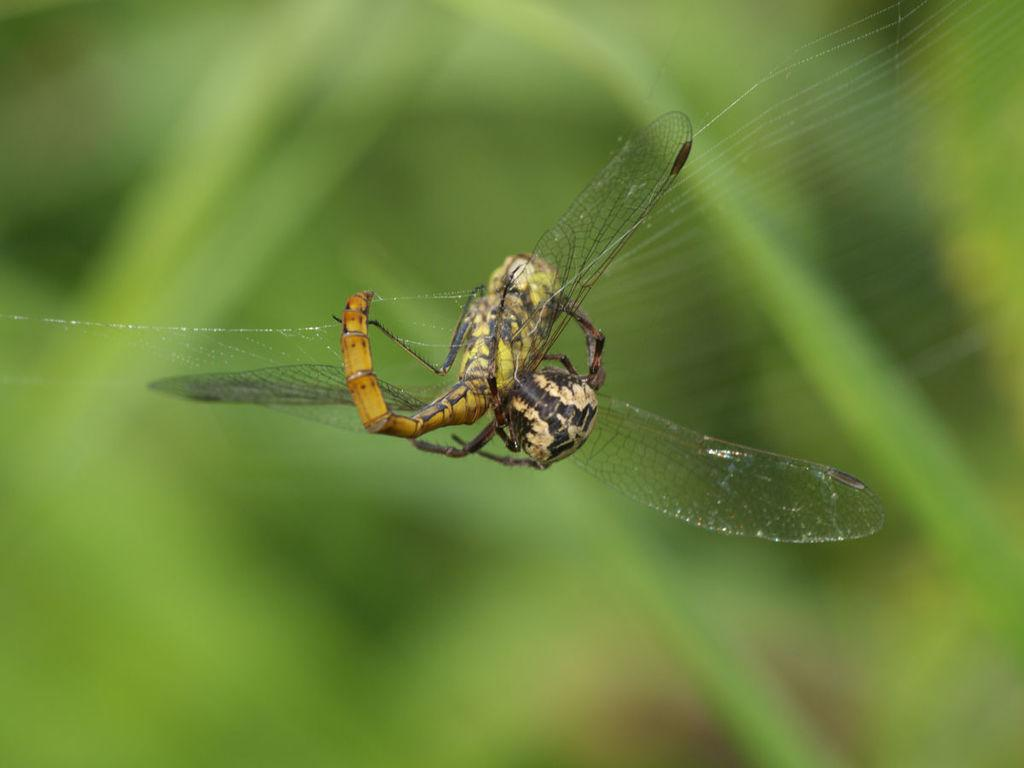What is the main subject of the image? There is an insect in the center of the image. Can you describe the background of the image? The background of the image is blurred. What type of lace is draped over the insect in the image? There is no lace present in the image; it features an insect in the center with a blurred background. 